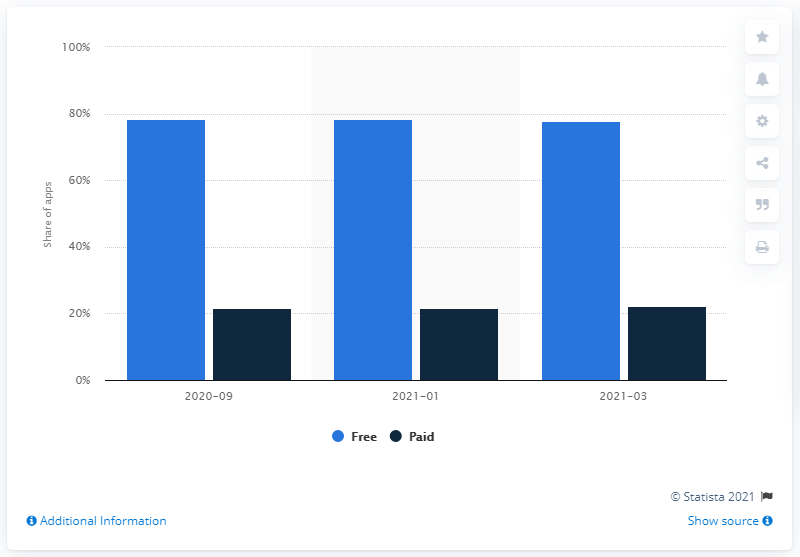Specify some key components in this picture. Out of all Android apps available in March 2021, 78.4% of them were available for free. In March 2021, approximately 22.1% of Android apps were downloaded for free. 